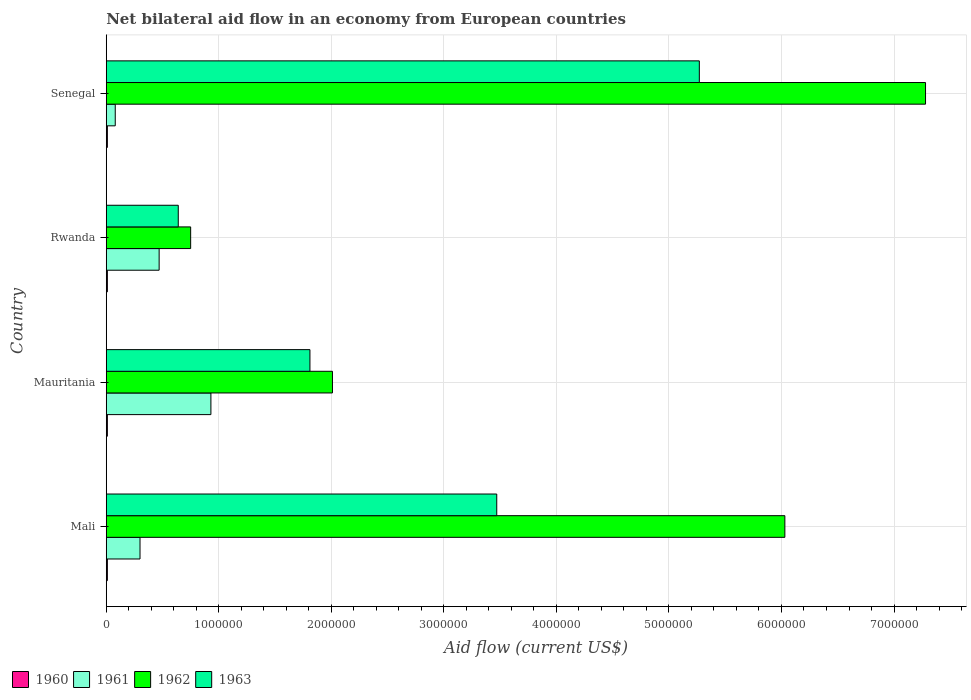Are the number of bars per tick equal to the number of legend labels?
Offer a terse response. Yes. Are the number of bars on each tick of the Y-axis equal?
Make the answer very short. Yes. How many bars are there on the 4th tick from the bottom?
Offer a very short reply. 4. What is the label of the 2nd group of bars from the top?
Your response must be concise. Rwanda. In how many cases, is the number of bars for a given country not equal to the number of legend labels?
Ensure brevity in your answer.  0. What is the net bilateral aid flow in 1963 in Mali?
Provide a short and direct response. 3.47e+06. Across all countries, what is the maximum net bilateral aid flow in 1962?
Keep it short and to the point. 7.28e+06. Across all countries, what is the minimum net bilateral aid flow in 1962?
Ensure brevity in your answer.  7.50e+05. In which country was the net bilateral aid flow in 1962 maximum?
Offer a terse response. Senegal. In which country was the net bilateral aid flow in 1962 minimum?
Your answer should be compact. Rwanda. What is the total net bilateral aid flow in 1960 in the graph?
Provide a short and direct response. 4.00e+04. What is the difference between the net bilateral aid flow in 1961 in Mauritania and that in Senegal?
Provide a short and direct response. 8.50e+05. What is the average net bilateral aid flow in 1960 per country?
Your answer should be very brief. 10000. What is the difference between the net bilateral aid flow in 1961 and net bilateral aid flow in 1960 in Mauritania?
Ensure brevity in your answer.  9.20e+05. In how many countries, is the net bilateral aid flow in 1962 greater than 6000000 US$?
Your response must be concise. 2. What is the ratio of the net bilateral aid flow in 1961 in Mali to that in Rwanda?
Provide a succinct answer. 0.64. What is the difference between the highest and the second highest net bilateral aid flow in 1963?
Ensure brevity in your answer.  1.80e+06. Is it the case that in every country, the sum of the net bilateral aid flow in 1961 and net bilateral aid flow in 1960 is greater than the sum of net bilateral aid flow in 1963 and net bilateral aid flow in 1962?
Make the answer very short. Yes. What does the 1st bar from the top in Mauritania represents?
Your answer should be compact. 1963. What does the 3rd bar from the bottom in Senegal represents?
Keep it short and to the point. 1962. How many bars are there?
Make the answer very short. 16. Does the graph contain any zero values?
Provide a short and direct response. No. Does the graph contain grids?
Ensure brevity in your answer.  Yes. What is the title of the graph?
Ensure brevity in your answer.  Net bilateral aid flow in an economy from European countries. What is the label or title of the X-axis?
Your answer should be very brief. Aid flow (current US$). What is the label or title of the Y-axis?
Your response must be concise. Country. What is the Aid flow (current US$) of 1960 in Mali?
Offer a very short reply. 10000. What is the Aid flow (current US$) in 1962 in Mali?
Make the answer very short. 6.03e+06. What is the Aid flow (current US$) in 1963 in Mali?
Ensure brevity in your answer.  3.47e+06. What is the Aid flow (current US$) of 1961 in Mauritania?
Provide a succinct answer. 9.30e+05. What is the Aid flow (current US$) of 1962 in Mauritania?
Offer a very short reply. 2.01e+06. What is the Aid flow (current US$) in 1963 in Mauritania?
Provide a short and direct response. 1.81e+06. What is the Aid flow (current US$) in 1962 in Rwanda?
Ensure brevity in your answer.  7.50e+05. What is the Aid flow (current US$) in 1963 in Rwanda?
Give a very brief answer. 6.40e+05. What is the Aid flow (current US$) in 1960 in Senegal?
Your answer should be very brief. 10000. What is the Aid flow (current US$) of 1962 in Senegal?
Ensure brevity in your answer.  7.28e+06. What is the Aid flow (current US$) of 1963 in Senegal?
Provide a succinct answer. 5.27e+06. Across all countries, what is the maximum Aid flow (current US$) in 1960?
Offer a terse response. 10000. Across all countries, what is the maximum Aid flow (current US$) in 1961?
Keep it short and to the point. 9.30e+05. Across all countries, what is the maximum Aid flow (current US$) in 1962?
Make the answer very short. 7.28e+06. Across all countries, what is the maximum Aid flow (current US$) in 1963?
Your answer should be very brief. 5.27e+06. Across all countries, what is the minimum Aid flow (current US$) of 1962?
Ensure brevity in your answer.  7.50e+05. Across all countries, what is the minimum Aid flow (current US$) of 1963?
Offer a terse response. 6.40e+05. What is the total Aid flow (current US$) of 1960 in the graph?
Your response must be concise. 4.00e+04. What is the total Aid flow (current US$) in 1961 in the graph?
Provide a succinct answer. 1.78e+06. What is the total Aid flow (current US$) in 1962 in the graph?
Keep it short and to the point. 1.61e+07. What is the total Aid flow (current US$) in 1963 in the graph?
Your answer should be very brief. 1.12e+07. What is the difference between the Aid flow (current US$) in 1961 in Mali and that in Mauritania?
Your response must be concise. -6.30e+05. What is the difference between the Aid flow (current US$) in 1962 in Mali and that in Mauritania?
Make the answer very short. 4.02e+06. What is the difference between the Aid flow (current US$) in 1963 in Mali and that in Mauritania?
Ensure brevity in your answer.  1.66e+06. What is the difference between the Aid flow (current US$) of 1960 in Mali and that in Rwanda?
Offer a terse response. 0. What is the difference between the Aid flow (current US$) in 1961 in Mali and that in Rwanda?
Your answer should be compact. -1.70e+05. What is the difference between the Aid flow (current US$) in 1962 in Mali and that in Rwanda?
Your response must be concise. 5.28e+06. What is the difference between the Aid flow (current US$) in 1963 in Mali and that in Rwanda?
Make the answer very short. 2.83e+06. What is the difference between the Aid flow (current US$) of 1960 in Mali and that in Senegal?
Make the answer very short. 0. What is the difference between the Aid flow (current US$) in 1961 in Mali and that in Senegal?
Ensure brevity in your answer.  2.20e+05. What is the difference between the Aid flow (current US$) of 1962 in Mali and that in Senegal?
Offer a very short reply. -1.25e+06. What is the difference between the Aid flow (current US$) in 1963 in Mali and that in Senegal?
Keep it short and to the point. -1.80e+06. What is the difference between the Aid flow (current US$) in 1960 in Mauritania and that in Rwanda?
Ensure brevity in your answer.  0. What is the difference between the Aid flow (current US$) of 1961 in Mauritania and that in Rwanda?
Your answer should be compact. 4.60e+05. What is the difference between the Aid flow (current US$) in 1962 in Mauritania and that in Rwanda?
Provide a short and direct response. 1.26e+06. What is the difference between the Aid flow (current US$) in 1963 in Mauritania and that in Rwanda?
Your answer should be compact. 1.17e+06. What is the difference between the Aid flow (current US$) in 1961 in Mauritania and that in Senegal?
Your answer should be compact. 8.50e+05. What is the difference between the Aid flow (current US$) of 1962 in Mauritania and that in Senegal?
Ensure brevity in your answer.  -5.27e+06. What is the difference between the Aid flow (current US$) in 1963 in Mauritania and that in Senegal?
Your answer should be very brief. -3.46e+06. What is the difference between the Aid flow (current US$) in 1962 in Rwanda and that in Senegal?
Offer a very short reply. -6.53e+06. What is the difference between the Aid flow (current US$) in 1963 in Rwanda and that in Senegal?
Give a very brief answer. -4.63e+06. What is the difference between the Aid flow (current US$) in 1960 in Mali and the Aid flow (current US$) in 1961 in Mauritania?
Provide a short and direct response. -9.20e+05. What is the difference between the Aid flow (current US$) in 1960 in Mali and the Aid flow (current US$) in 1963 in Mauritania?
Give a very brief answer. -1.80e+06. What is the difference between the Aid flow (current US$) in 1961 in Mali and the Aid flow (current US$) in 1962 in Mauritania?
Keep it short and to the point. -1.71e+06. What is the difference between the Aid flow (current US$) of 1961 in Mali and the Aid flow (current US$) of 1963 in Mauritania?
Provide a succinct answer. -1.51e+06. What is the difference between the Aid flow (current US$) of 1962 in Mali and the Aid flow (current US$) of 1963 in Mauritania?
Provide a short and direct response. 4.22e+06. What is the difference between the Aid flow (current US$) in 1960 in Mali and the Aid flow (current US$) in 1961 in Rwanda?
Your response must be concise. -4.60e+05. What is the difference between the Aid flow (current US$) of 1960 in Mali and the Aid flow (current US$) of 1962 in Rwanda?
Offer a very short reply. -7.40e+05. What is the difference between the Aid flow (current US$) in 1960 in Mali and the Aid flow (current US$) in 1963 in Rwanda?
Your answer should be compact. -6.30e+05. What is the difference between the Aid flow (current US$) of 1961 in Mali and the Aid flow (current US$) of 1962 in Rwanda?
Your answer should be very brief. -4.50e+05. What is the difference between the Aid flow (current US$) of 1961 in Mali and the Aid flow (current US$) of 1963 in Rwanda?
Provide a succinct answer. -3.40e+05. What is the difference between the Aid flow (current US$) of 1962 in Mali and the Aid flow (current US$) of 1963 in Rwanda?
Your response must be concise. 5.39e+06. What is the difference between the Aid flow (current US$) of 1960 in Mali and the Aid flow (current US$) of 1961 in Senegal?
Make the answer very short. -7.00e+04. What is the difference between the Aid flow (current US$) of 1960 in Mali and the Aid flow (current US$) of 1962 in Senegal?
Offer a terse response. -7.27e+06. What is the difference between the Aid flow (current US$) in 1960 in Mali and the Aid flow (current US$) in 1963 in Senegal?
Offer a very short reply. -5.26e+06. What is the difference between the Aid flow (current US$) in 1961 in Mali and the Aid flow (current US$) in 1962 in Senegal?
Your response must be concise. -6.98e+06. What is the difference between the Aid flow (current US$) in 1961 in Mali and the Aid flow (current US$) in 1963 in Senegal?
Keep it short and to the point. -4.97e+06. What is the difference between the Aid flow (current US$) of 1962 in Mali and the Aid flow (current US$) of 1963 in Senegal?
Your answer should be very brief. 7.60e+05. What is the difference between the Aid flow (current US$) in 1960 in Mauritania and the Aid flow (current US$) in 1961 in Rwanda?
Offer a terse response. -4.60e+05. What is the difference between the Aid flow (current US$) in 1960 in Mauritania and the Aid flow (current US$) in 1962 in Rwanda?
Offer a very short reply. -7.40e+05. What is the difference between the Aid flow (current US$) of 1960 in Mauritania and the Aid flow (current US$) of 1963 in Rwanda?
Your answer should be very brief. -6.30e+05. What is the difference between the Aid flow (current US$) of 1961 in Mauritania and the Aid flow (current US$) of 1962 in Rwanda?
Your answer should be very brief. 1.80e+05. What is the difference between the Aid flow (current US$) in 1961 in Mauritania and the Aid flow (current US$) in 1963 in Rwanda?
Your answer should be compact. 2.90e+05. What is the difference between the Aid flow (current US$) of 1962 in Mauritania and the Aid flow (current US$) of 1963 in Rwanda?
Your response must be concise. 1.37e+06. What is the difference between the Aid flow (current US$) in 1960 in Mauritania and the Aid flow (current US$) in 1962 in Senegal?
Offer a terse response. -7.27e+06. What is the difference between the Aid flow (current US$) in 1960 in Mauritania and the Aid flow (current US$) in 1963 in Senegal?
Give a very brief answer. -5.26e+06. What is the difference between the Aid flow (current US$) of 1961 in Mauritania and the Aid flow (current US$) of 1962 in Senegal?
Your answer should be very brief. -6.35e+06. What is the difference between the Aid flow (current US$) of 1961 in Mauritania and the Aid flow (current US$) of 1963 in Senegal?
Make the answer very short. -4.34e+06. What is the difference between the Aid flow (current US$) in 1962 in Mauritania and the Aid flow (current US$) in 1963 in Senegal?
Your answer should be very brief. -3.26e+06. What is the difference between the Aid flow (current US$) of 1960 in Rwanda and the Aid flow (current US$) of 1962 in Senegal?
Give a very brief answer. -7.27e+06. What is the difference between the Aid flow (current US$) of 1960 in Rwanda and the Aid flow (current US$) of 1963 in Senegal?
Make the answer very short. -5.26e+06. What is the difference between the Aid flow (current US$) in 1961 in Rwanda and the Aid flow (current US$) in 1962 in Senegal?
Your answer should be compact. -6.81e+06. What is the difference between the Aid flow (current US$) of 1961 in Rwanda and the Aid flow (current US$) of 1963 in Senegal?
Provide a succinct answer. -4.80e+06. What is the difference between the Aid flow (current US$) of 1962 in Rwanda and the Aid flow (current US$) of 1963 in Senegal?
Offer a very short reply. -4.52e+06. What is the average Aid flow (current US$) in 1961 per country?
Make the answer very short. 4.45e+05. What is the average Aid flow (current US$) in 1962 per country?
Keep it short and to the point. 4.02e+06. What is the average Aid flow (current US$) of 1963 per country?
Keep it short and to the point. 2.80e+06. What is the difference between the Aid flow (current US$) of 1960 and Aid flow (current US$) of 1961 in Mali?
Your answer should be very brief. -2.90e+05. What is the difference between the Aid flow (current US$) of 1960 and Aid flow (current US$) of 1962 in Mali?
Ensure brevity in your answer.  -6.02e+06. What is the difference between the Aid flow (current US$) of 1960 and Aid flow (current US$) of 1963 in Mali?
Offer a very short reply. -3.46e+06. What is the difference between the Aid flow (current US$) of 1961 and Aid flow (current US$) of 1962 in Mali?
Offer a terse response. -5.73e+06. What is the difference between the Aid flow (current US$) of 1961 and Aid flow (current US$) of 1963 in Mali?
Your response must be concise. -3.17e+06. What is the difference between the Aid flow (current US$) of 1962 and Aid flow (current US$) of 1963 in Mali?
Offer a terse response. 2.56e+06. What is the difference between the Aid flow (current US$) in 1960 and Aid flow (current US$) in 1961 in Mauritania?
Keep it short and to the point. -9.20e+05. What is the difference between the Aid flow (current US$) in 1960 and Aid flow (current US$) in 1962 in Mauritania?
Keep it short and to the point. -2.00e+06. What is the difference between the Aid flow (current US$) of 1960 and Aid flow (current US$) of 1963 in Mauritania?
Ensure brevity in your answer.  -1.80e+06. What is the difference between the Aid flow (current US$) of 1961 and Aid flow (current US$) of 1962 in Mauritania?
Make the answer very short. -1.08e+06. What is the difference between the Aid flow (current US$) of 1961 and Aid flow (current US$) of 1963 in Mauritania?
Offer a terse response. -8.80e+05. What is the difference between the Aid flow (current US$) of 1960 and Aid flow (current US$) of 1961 in Rwanda?
Provide a succinct answer. -4.60e+05. What is the difference between the Aid flow (current US$) of 1960 and Aid flow (current US$) of 1962 in Rwanda?
Make the answer very short. -7.40e+05. What is the difference between the Aid flow (current US$) of 1960 and Aid flow (current US$) of 1963 in Rwanda?
Your answer should be very brief. -6.30e+05. What is the difference between the Aid flow (current US$) of 1961 and Aid flow (current US$) of 1962 in Rwanda?
Your answer should be very brief. -2.80e+05. What is the difference between the Aid flow (current US$) of 1961 and Aid flow (current US$) of 1963 in Rwanda?
Provide a short and direct response. -1.70e+05. What is the difference between the Aid flow (current US$) in 1960 and Aid flow (current US$) in 1962 in Senegal?
Give a very brief answer. -7.27e+06. What is the difference between the Aid flow (current US$) of 1960 and Aid flow (current US$) of 1963 in Senegal?
Make the answer very short. -5.26e+06. What is the difference between the Aid flow (current US$) of 1961 and Aid flow (current US$) of 1962 in Senegal?
Your answer should be very brief. -7.20e+06. What is the difference between the Aid flow (current US$) of 1961 and Aid flow (current US$) of 1963 in Senegal?
Your answer should be very brief. -5.19e+06. What is the difference between the Aid flow (current US$) of 1962 and Aid flow (current US$) of 1963 in Senegal?
Ensure brevity in your answer.  2.01e+06. What is the ratio of the Aid flow (current US$) in 1961 in Mali to that in Mauritania?
Your response must be concise. 0.32. What is the ratio of the Aid flow (current US$) of 1963 in Mali to that in Mauritania?
Give a very brief answer. 1.92. What is the ratio of the Aid flow (current US$) in 1960 in Mali to that in Rwanda?
Keep it short and to the point. 1. What is the ratio of the Aid flow (current US$) of 1961 in Mali to that in Rwanda?
Offer a very short reply. 0.64. What is the ratio of the Aid flow (current US$) in 1962 in Mali to that in Rwanda?
Provide a succinct answer. 8.04. What is the ratio of the Aid flow (current US$) of 1963 in Mali to that in Rwanda?
Your answer should be very brief. 5.42. What is the ratio of the Aid flow (current US$) of 1960 in Mali to that in Senegal?
Make the answer very short. 1. What is the ratio of the Aid flow (current US$) of 1961 in Mali to that in Senegal?
Offer a very short reply. 3.75. What is the ratio of the Aid flow (current US$) of 1962 in Mali to that in Senegal?
Your response must be concise. 0.83. What is the ratio of the Aid flow (current US$) of 1963 in Mali to that in Senegal?
Ensure brevity in your answer.  0.66. What is the ratio of the Aid flow (current US$) in 1960 in Mauritania to that in Rwanda?
Ensure brevity in your answer.  1. What is the ratio of the Aid flow (current US$) of 1961 in Mauritania to that in Rwanda?
Provide a short and direct response. 1.98. What is the ratio of the Aid flow (current US$) in 1962 in Mauritania to that in Rwanda?
Provide a short and direct response. 2.68. What is the ratio of the Aid flow (current US$) of 1963 in Mauritania to that in Rwanda?
Keep it short and to the point. 2.83. What is the ratio of the Aid flow (current US$) of 1961 in Mauritania to that in Senegal?
Offer a terse response. 11.62. What is the ratio of the Aid flow (current US$) in 1962 in Mauritania to that in Senegal?
Make the answer very short. 0.28. What is the ratio of the Aid flow (current US$) in 1963 in Mauritania to that in Senegal?
Your answer should be very brief. 0.34. What is the ratio of the Aid flow (current US$) of 1960 in Rwanda to that in Senegal?
Ensure brevity in your answer.  1. What is the ratio of the Aid flow (current US$) in 1961 in Rwanda to that in Senegal?
Make the answer very short. 5.88. What is the ratio of the Aid flow (current US$) in 1962 in Rwanda to that in Senegal?
Offer a very short reply. 0.1. What is the ratio of the Aid flow (current US$) of 1963 in Rwanda to that in Senegal?
Your response must be concise. 0.12. What is the difference between the highest and the second highest Aid flow (current US$) in 1961?
Your response must be concise. 4.60e+05. What is the difference between the highest and the second highest Aid flow (current US$) of 1962?
Ensure brevity in your answer.  1.25e+06. What is the difference between the highest and the second highest Aid flow (current US$) in 1963?
Make the answer very short. 1.80e+06. What is the difference between the highest and the lowest Aid flow (current US$) in 1960?
Your answer should be compact. 0. What is the difference between the highest and the lowest Aid flow (current US$) of 1961?
Make the answer very short. 8.50e+05. What is the difference between the highest and the lowest Aid flow (current US$) in 1962?
Keep it short and to the point. 6.53e+06. What is the difference between the highest and the lowest Aid flow (current US$) of 1963?
Provide a succinct answer. 4.63e+06. 